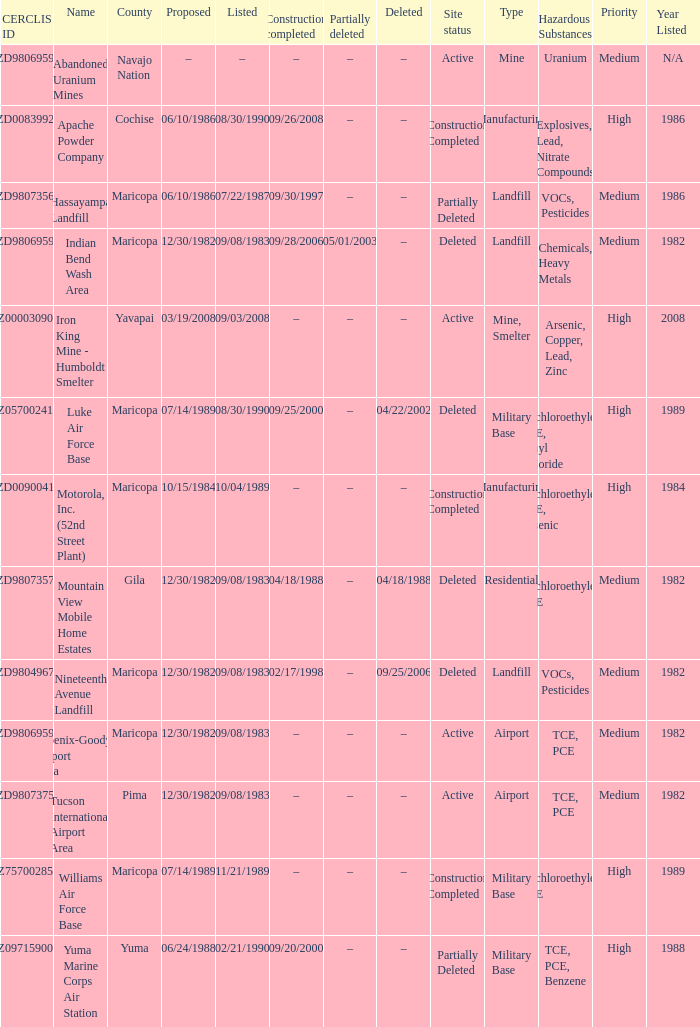When was the site listed when the county is cochise? 08/30/1990. 